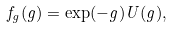Convert formula to latex. <formula><loc_0><loc_0><loc_500><loc_500>f _ { g } ( g ) = \exp ( - g ) U ( g ) ,</formula> 